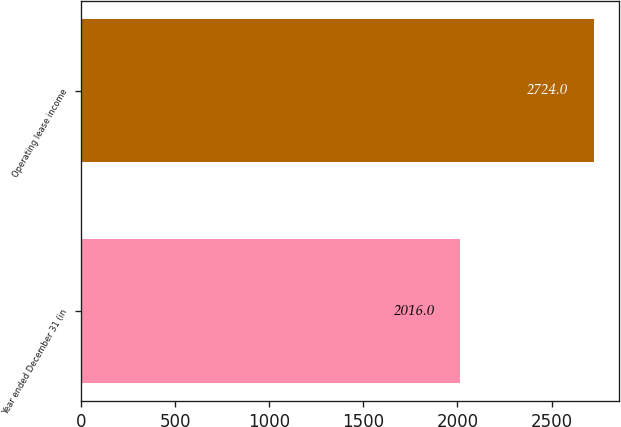<chart> <loc_0><loc_0><loc_500><loc_500><bar_chart><fcel>Year ended December 31 (in<fcel>Operating lease income<nl><fcel>2016<fcel>2724<nl></chart> 